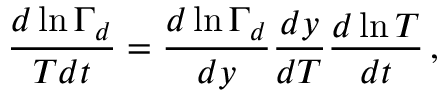<formula> <loc_0><loc_0><loc_500><loc_500>\frac { d \ln \Gamma _ { d } } { T d t } = \frac { d \ln \Gamma _ { d } } { d y } \frac { d y } { d T } \frac { d \ln T } { d t } \, ,</formula> 